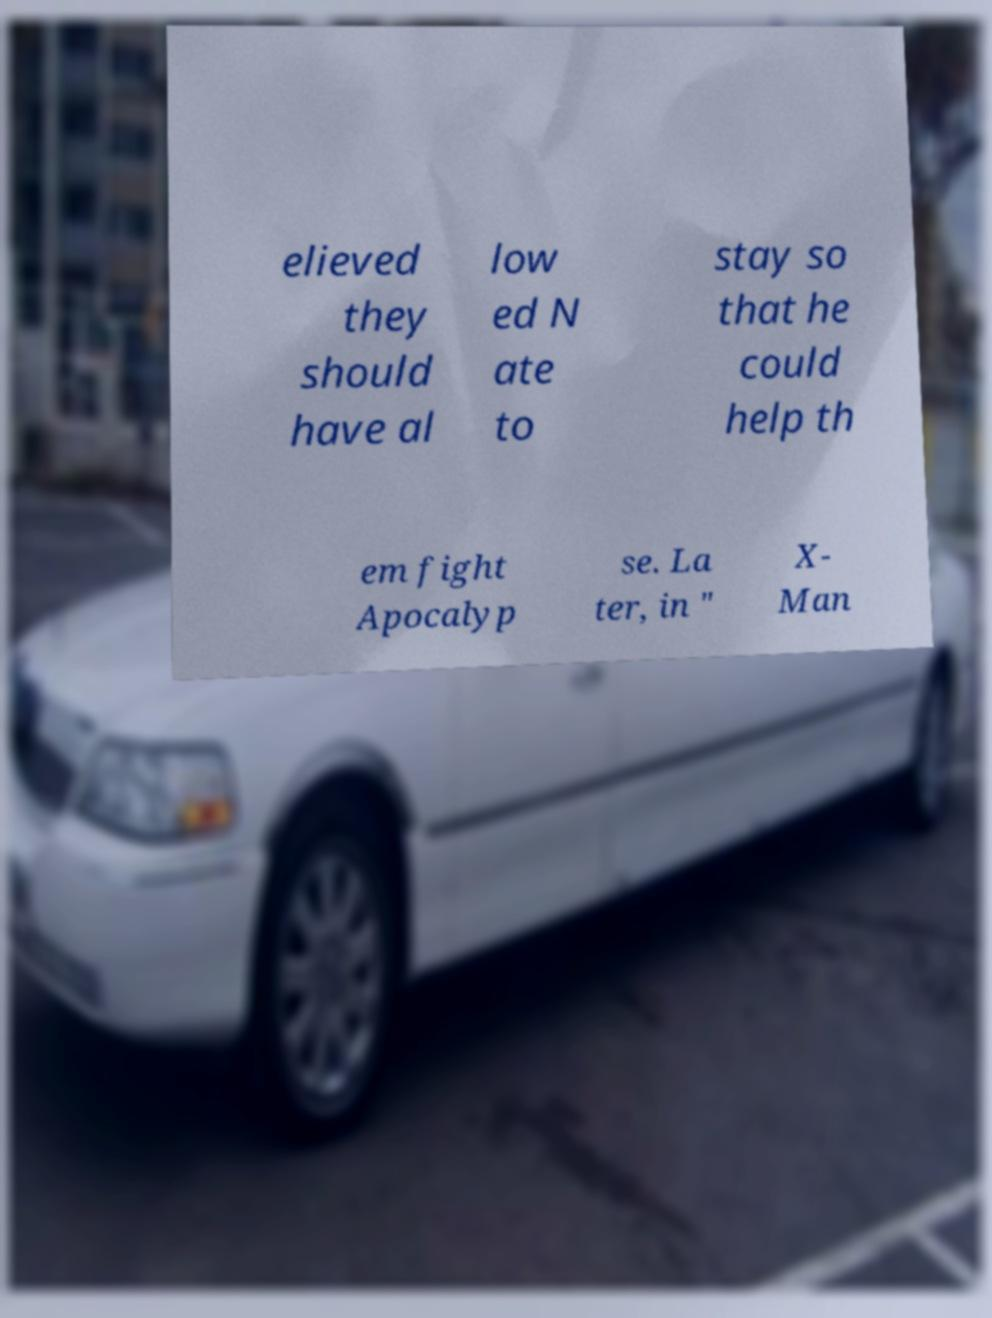Could you assist in decoding the text presented in this image and type it out clearly? elieved they should have al low ed N ate to stay so that he could help th em fight Apocalyp se. La ter, in " X- Man 